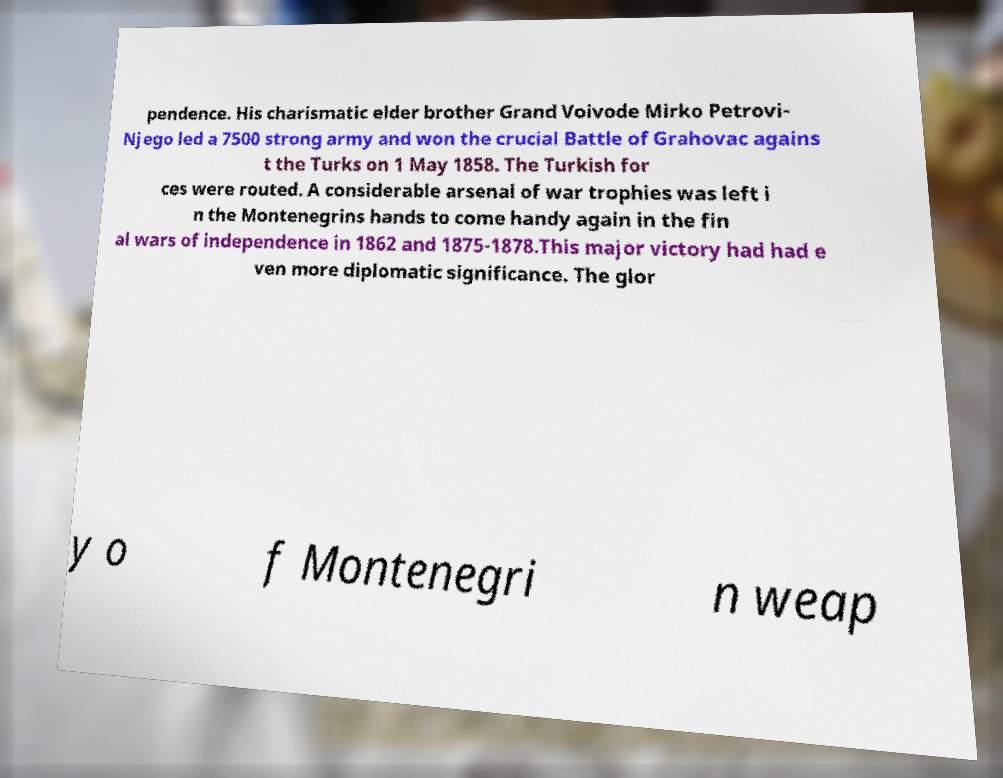Could you assist in decoding the text presented in this image and type it out clearly? pendence. His charismatic elder brother Grand Voivode Mirko Petrovi- Njego led a 7500 strong army and won the crucial Battle of Grahovac agains t the Turks on 1 May 1858. The Turkish for ces were routed. A considerable arsenal of war trophies was left i n the Montenegrins hands to come handy again in the fin al wars of independence in 1862 and 1875-1878.This major victory had had e ven more diplomatic significance. The glor y o f Montenegri n weap 